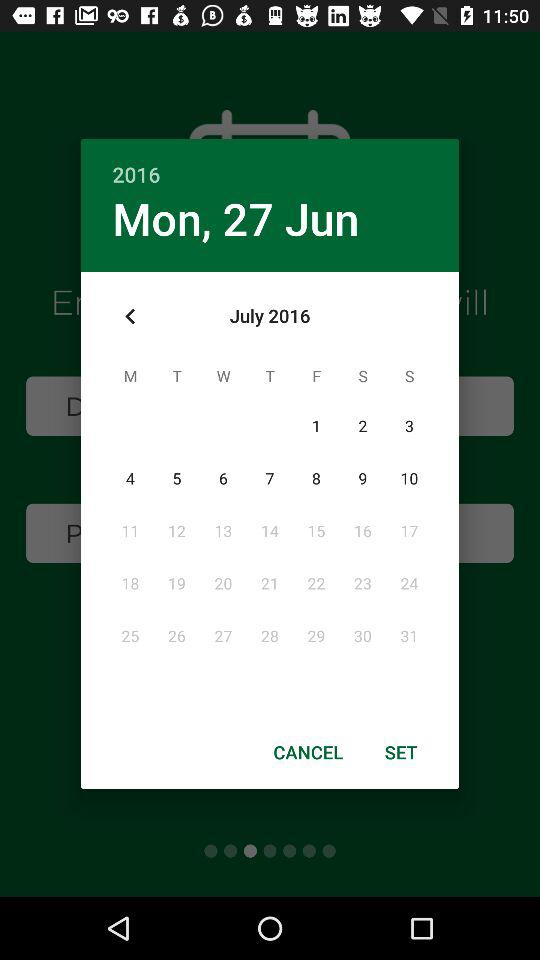Which date was selected? The selected date was Monday, June 27, 2016. 